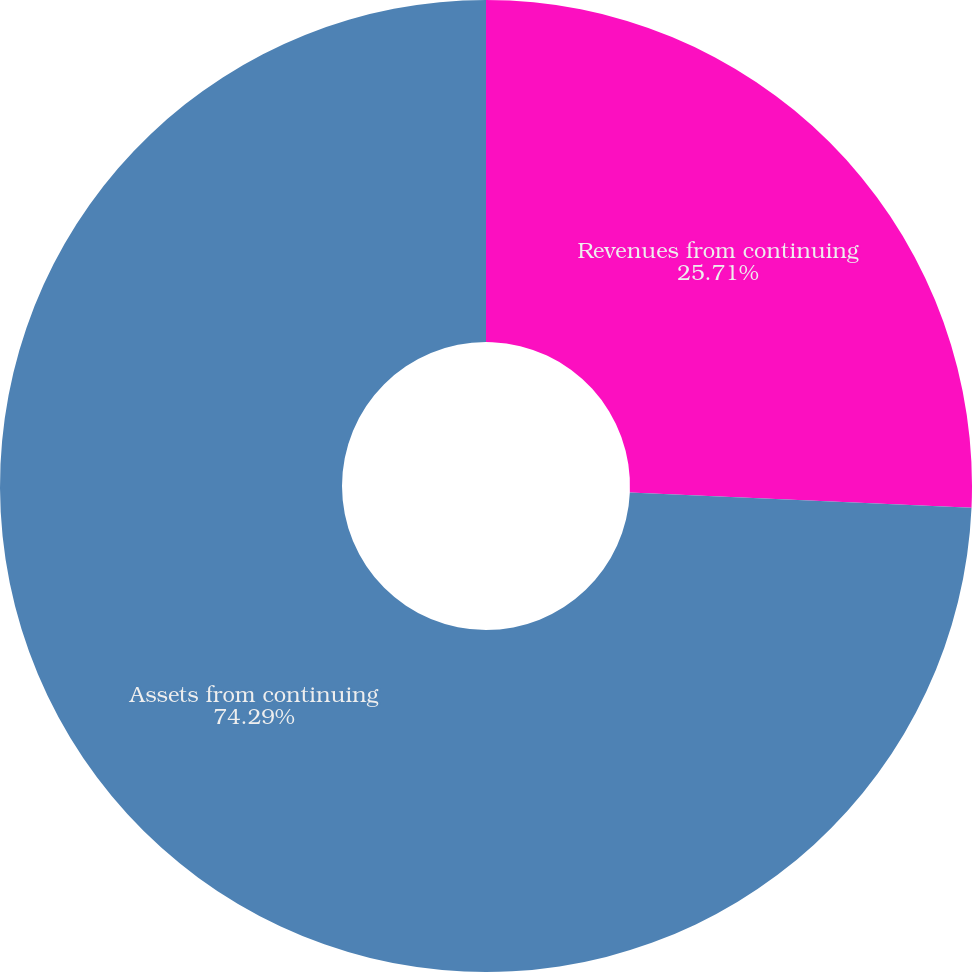<chart> <loc_0><loc_0><loc_500><loc_500><pie_chart><fcel>Revenues from continuing<fcel>Assets from continuing<nl><fcel>25.71%<fcel>74.29%<nl></chart> 